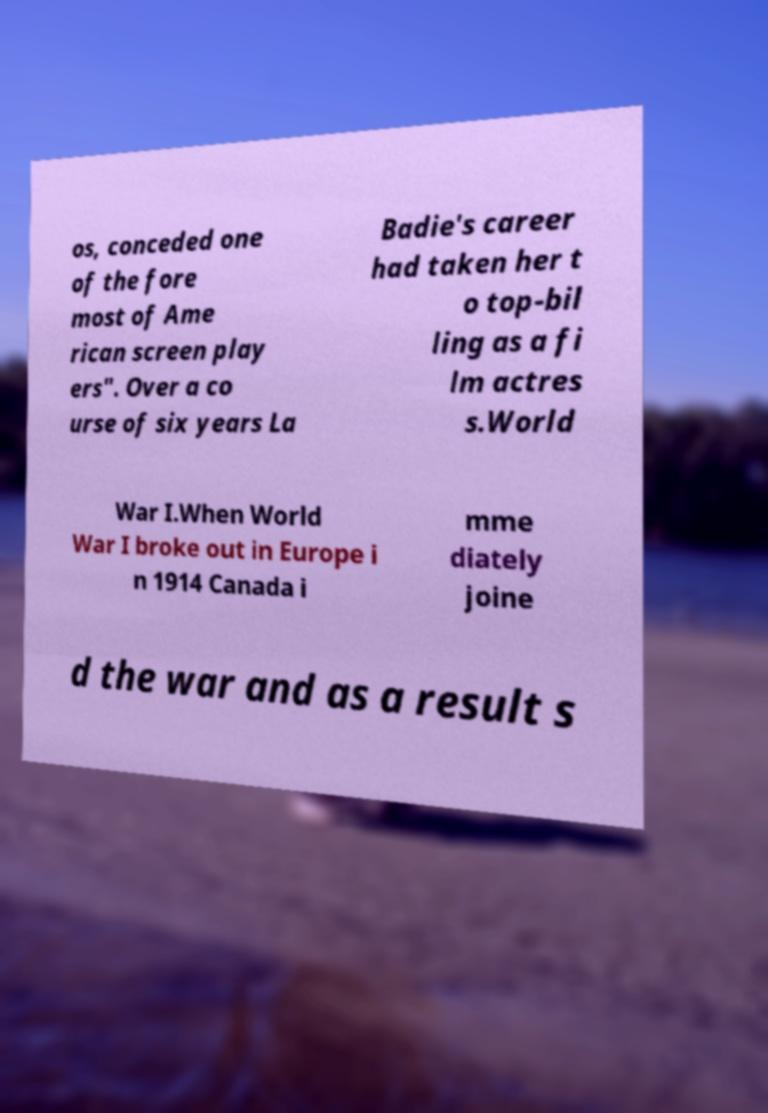Can you read and provide the text displayed in the image?This photo seems to have some interesting text. Can you extract and type it out for me? os, conceded one of the fore most of Ame rican screen play ers". Over a co urse of six years La Badie's career had taken her t o top-bil ling as a fi lm actres s.World War I.When World War I broke out in Europe i n 1914 Canada i mme diately joine d the war and as a result s 